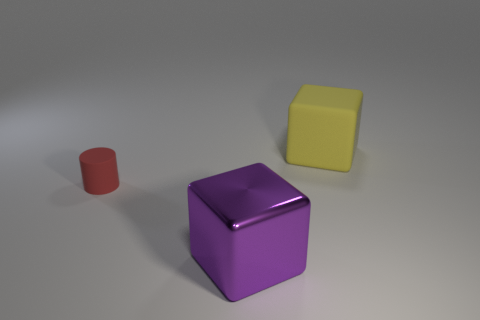What number of other things are there of the same shape as the large yellow matte thing?
Your response must be concise. 1. Does the purple object have the same size as the yellow rubber cube?
Keep it short and to the point. Yes. Is there a big yellow matte cylinder?
Keep it short and to the point. No. Is there any other thing that has the same material as the small cylinder?
Give a very brief answer. Yes. Are there any small objects made of the same material as the tiny cylinder?
Your answer should be compact. No. There is another block that is the same size as the yellow block; what is its material?
Your response must be concise. Metal. How many red objects are the same shape as the purple object?
Make the answer very short. 0. There is a red cylinder that is the same material as the yellow block; what size is it?
Your answer should be compact. Small. There is a thing that is both right of the small red matte object and behind the large purple shiny cube; what material is it?
Your answer should be compact. Rubber. How many other red matte objects have the same size as the red matte object?
Your answer should be compact. 0. 